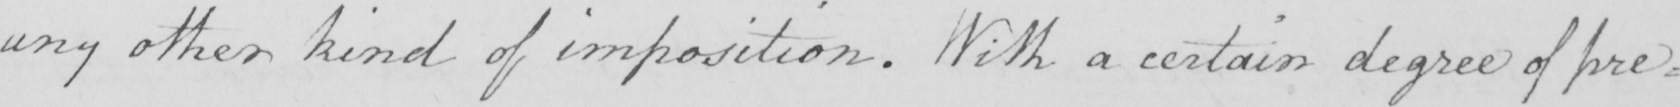Can you tell me what this handwritten text says? any other kind of imposition . With a certain degree of pre= 